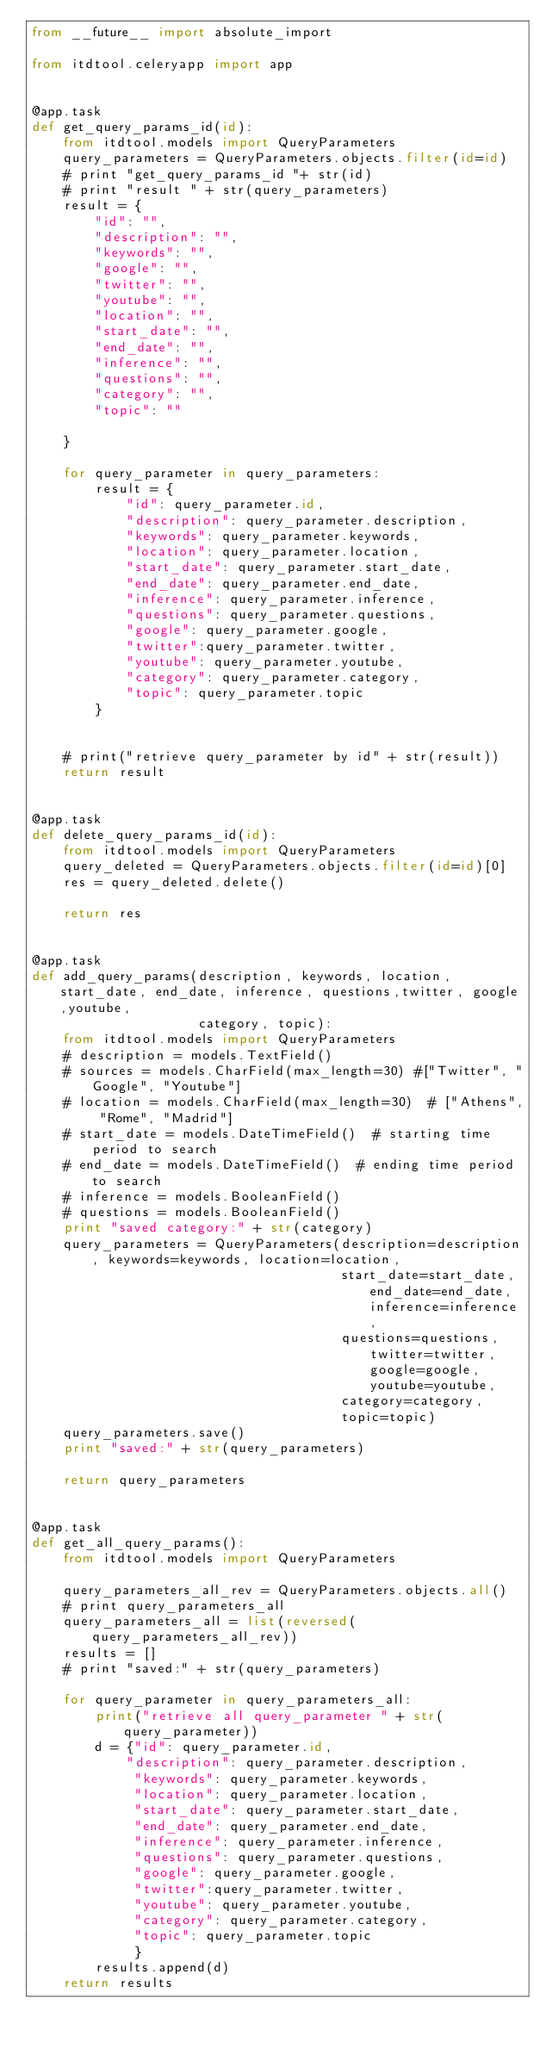Convert code to text. <code><loc_0><loc_0><loc_500><loc_500><_Python_>from __future__ import absolute_import

from itdtool.celeryapp import app


@app.task
def get_query_params_id(id):
    from itdtool.models import QueryParameters
    query_parameters = QueryParameters.objects.filter(id=id)
    # print "get_query_params_id "+ str(id)
    # print "result " + str(query_parameters)
    result = {
        "id": "",
        "description": "",
        "keywords": "",
        "google": "",
        "twitter": "",
        "youtube": "",
        "location": "",
        "start_date": "",
        "end_date": "",
        "inference": "",
        "questions": "",
        "category": "",
        "topic": ""

    }

    for query_parameter in query_parameters:
        result = {
            "id": query_parameter.id,
            "description": query_parameter.description,
            "keywords": query_parameter.keywords,
            "location": query_parameter.location,
            "start_date": query_parameter.start_date,
            "end_date": query_parameter.end_date,
            "inference": query_parameter.inference,
            "questions": query_parameter.questions,
            "google": query_parameter.google,
            "twitter":query_parameter.twitter,
            "youtube": query_parameter.youtube,
            "category": query_parameter.category,
            "topic": query_parameter.topic
        }


    # print("retrieve query_parameter by id" + str(result))
    return result


@app.task
def delete_query_params_id(id):
    from itdtool.models import QueryParameters
    query_deleted = QueryParameters.objects.filter(id=id)[0]
    res = query_deleted.delete()

    return res


@app.task
def add_query_params(description, keywords, location, start_date, end_date, inference, questions,twitter, google,youtube,
                     category, topic):
    from itdtool.models import QueryParameters
    # description = models.TextField()
    # sources = models.CharField(max_length=30) #["Twitter", "Google", "Youtube"]
    # location = models.CharField(max_length=30)  # ["Athens", "Rome", "Madrid"]
    # start_date = models.DateTimeField()  # starting time period to search
    # end_date = models.DateTimeField()  # ending time period to search
    # inference = models.BooleanField()
    # questions = models.BooleanField()
    print "saved category:" + str(category)
    query_parameters = QueryParameters(description=description, keywords=keywords, location=location,
                                       start_date=start_date, end_date=end_date, inference=inference,
                                       questions=questions,twitter=twitter, google=google,youtube=youtube,
                                       category=category,
                                       topic=topic)
    query_parameters.save()
    print "saved:" + str(query_parameters)

    return query_parameters


@app.task
def get_all_query_params():
    from itdtool.models import QueryParameters

    query_parameters_all_rev = QueryParameters.objects.all()
    # print query_parameters_all
    query_parameters_all = list(reversed(query_parameters_all_rev))
    results = []
    # print "saved:" + str(query_parameters)

    for query_parameter in query_parameters_all:
        print("retrieve all query_parameter " + str(query_parameter))
        d = {"id": query_parameter.id,
            "description": query_parameter.description,
             "keywords": query_parameter.keywords,
             "location": query_parameter.location,
             "start_date": query_parameter.start_date,
             "end_date": query_parameter.end_date,
             "inference": query_parameter.inference,
             "questions": query_parameter.questions,
             "google": query_parameter.google,
             "twitter":query_parameter.twitter,
             "youtube": query_parameter.youtube,
             "category": query_parameter.category,
             "topic": query_parameter.topic
             }
        results.append(d)
    return results

</code> 